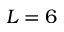<formula> <loc_0><loc_0><loc_500><loc_500>L = 6</formula> 